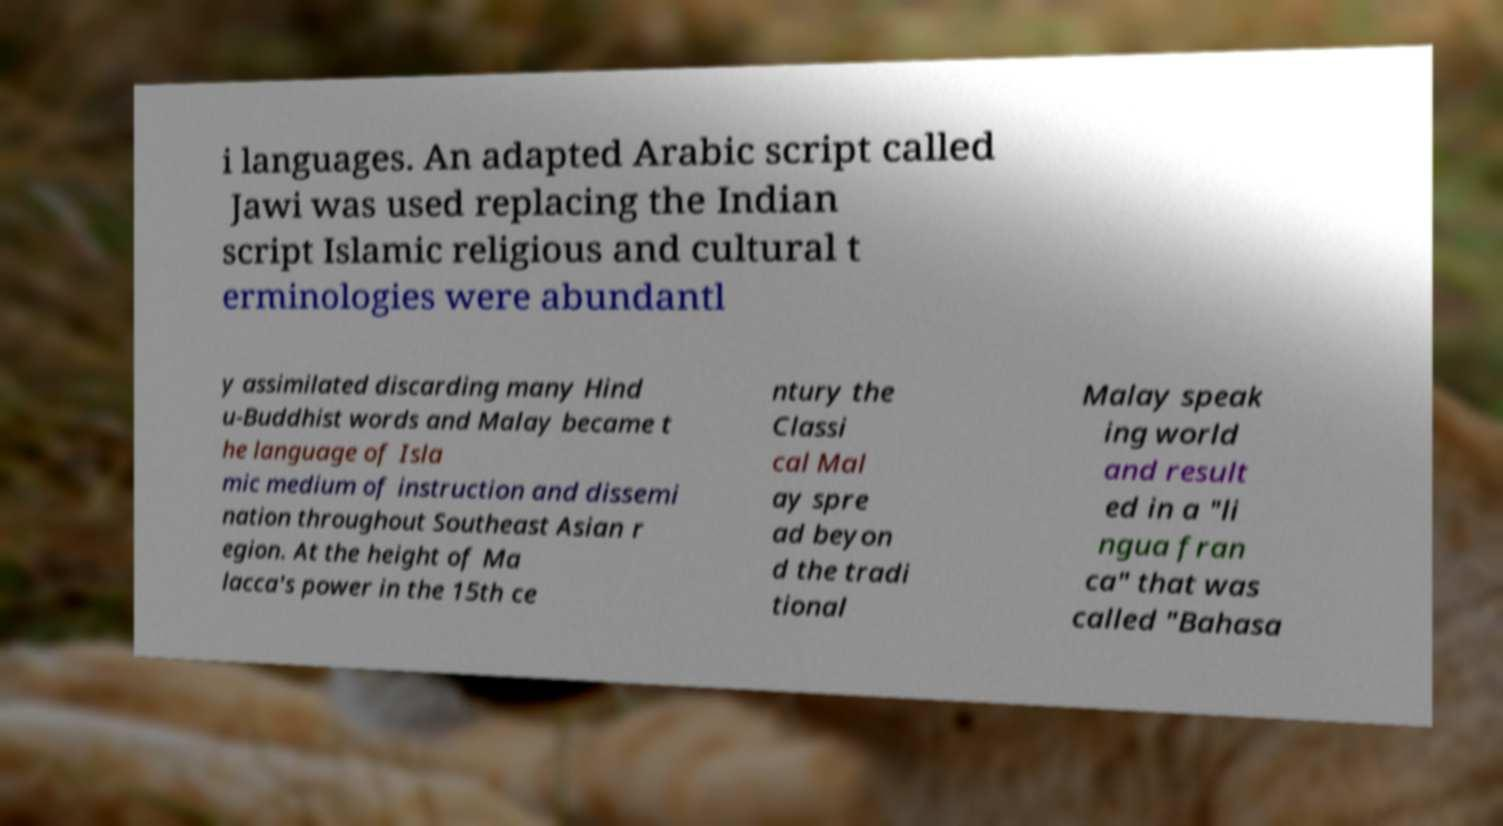Please read and relay the text visible in this image. What does it say? i languages. An adapted Arabic script called Jawi was used replacing the Indian script Islamic religious and cultural t erminologies were abundantl y assimilated discarding many Hind u-Buddhist words and Malay became t he language of Isla mic medium of instruction and dissemi nation throughout Southeast Asian r egion. At the height of Ma lacca's power in the 15th ce ntury the Classi cal Mal ay spre ad beyon d the tradi tional Malay speak ing world and result ed in a "li ngua fran ca" that was called "Bahasa 